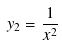<formula> <loc_0><loc_0><loc_500><loc_500>y _ { 2 } = \frac { 1 } { x ^ { 2 } }</formula> 